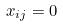<formula> <loc_0><loc_0><loc_500><loc_500>x _ { i j } = 0</formula> 